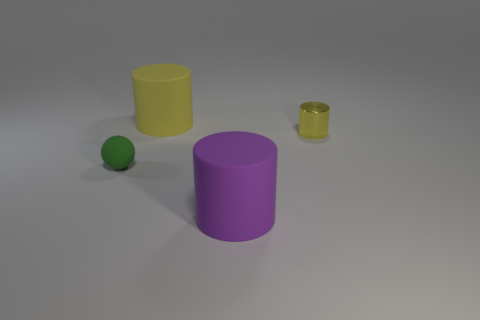Add 3 yellow objects. How many objects exist? 7 Subtract all cylinders. How many objects are left? 1 Add 3 tiny yellow shiny cylinders. How many tiny yellow shiny cylinders are left? 4 Add 2 small metal objects. How many small metal objects exist? 3 Subtract 0 purple blocks. How many objects are left? 4 Subtract all big green cubes. Subtract all large yellow rubber cylinders. How many objects are left? 3 